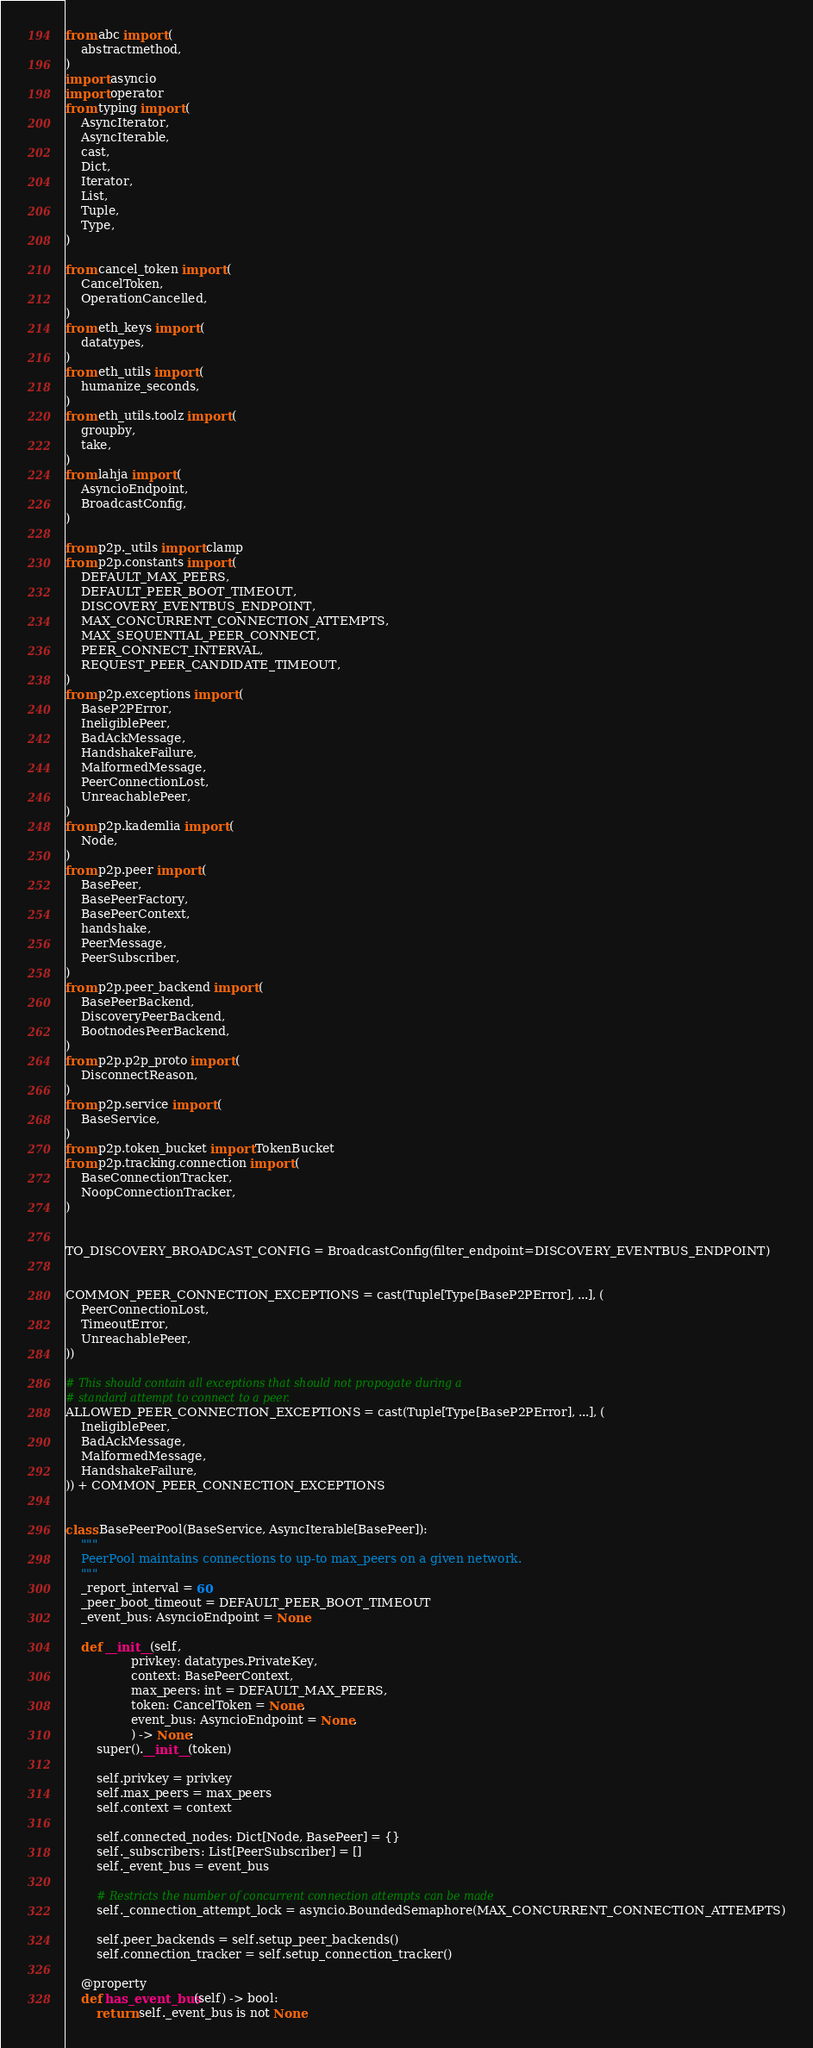Convert code to text. <code><loc_0><loc_0><loc_500><loc_500><_Python_>from abc import (
    abstractmethod,
)
import asyncio
import operator
from typing import (
    AsyncIterator,
    AsyncIterable,
    cast,
    Dict,
    Iterator,
    List,
    Tuple,
    Type,
)

from cancel_token import (
    CancelToken,
    OperationCancelled,
)
from eth_keys import (
    datatypes,
)
from eth_utils import (
    humanize_seconds,
)
from eth_utils.toolz import (
    groupby,
    take,
)
from lahja import (
    AsyncioEndpoint,
    BroadcastConfig,
)

from p2p._utils import clamp
from p2p.constants import (
    DEFAULT_MAX_PEERS,
    DEFAULT_PEER_BOOT_TIMEOUT,
    DISCOVERY_EVENTBUS_ENDPOINT,
    MAX_CONCURRENT_CONNECTION_ATTEMPTS,
    MAX_SEQUENTIAL_PEER_CONNECT,
    PEER_CONNECT_INTERVAL,
    REQUEST_PEER_CANDIDATE_TIMEOUT,
)
from p2p.exceptions import (
    BaseP2PError,
    IneligiblePeer,
    BadAckMessage,
    HandshakeFailure,
    MalformedMessage,
    PeerConnectionLost,
    UnreachablePeer,
)
from p2p.kademlia import (
    Node,
)
from p2p.peer import (
    BasePeer,
    BasePeerFactory,
    BasePeerContext,
    handshake,
    PeerMessage,
    PeerSubscriber,
)
from p2p.peer_backend import (
    BasePeerBackend,
    DiscoveryPeerBackend,
    BootnodesPeerBackend,
)
from p2p.p2p_proto import (
    DisconnectReason,
)
from p2p.service import (
    BaseService,
)
from p2p.token_bucket import TokenBucket
from p2p.tracking.connection import (
    BaseConnectionTracker,
    NoopConnectionTracker,
)


TO_DISCOVERY_BROADCAST_CONFIG = BroadcastConfig(filter_endpoint=DISCOVERY_EVENTBUS_ENDPOINT)


COMMON_PEER_CONNECTION_EXCEPTIONS = cast(Tuple[Type[BaseP2PError], ...], (
    PeerConnectionLost,
    TimeoutError,
    UnreachablePeer,
))

# This should contain all exceptions that should not propogate during a
# standard attempt to connect to a peer.
ALLOWED_PEER_CONNECTION_EXCEPTIONS = cast(Tuple[Type[BaseP2PError], ...], (
    IneligiblePeer,
    BadAckMessage,
    MalformedMessage,
    HandshakeFailure,
)) + COMMON_PEER_CONNECTION_EXCEPTIONS


class BasePeerPool(BaseService, AsyncIterable[BasePeer]):
    """
    PeerPool maintains connections to up-to max_peers on a given network.
    """
    _report_interval = 60
    _peer_boot_timeout = DEFAULT_PEER_BOOT_TIMEOUT
    _event_bus: AsyncioEndpoint = None

    def __init__(self,
                 privkey: datatypes.PrivateKey,
                 context: BasePeerContext,
                 max_peers: int = DEFAULT_MAX_PEERS,
                 token: CancelToken = None,
                 event_bus: AsyncioEndpoint = None,
                 ) -> None:
        super().__init__(token)

        self.privkey = privkey
        self.max_peers = max_peers
        self.context = context

        self.connected_nodes: Dict[Node, BasePeer] = {}
        self._subscribers: List[PeerSubscriber] = []
        self._event_bus = event_bus

        # Restricts the number of concurrent connection attempts can be made
        self._connection_attempt_lock = asyncio.BoundedSemaphore(MAX_CONCURRENT_CONNECTION_ATTEMPTS)

        self.peer_backends = self.setup_peer_backends()
        self.connection_tracker = self.setup_connection_tracker()

    @property
    def has_event_bus(self) -> bool:
        return self._event_bus is not None
</code> 